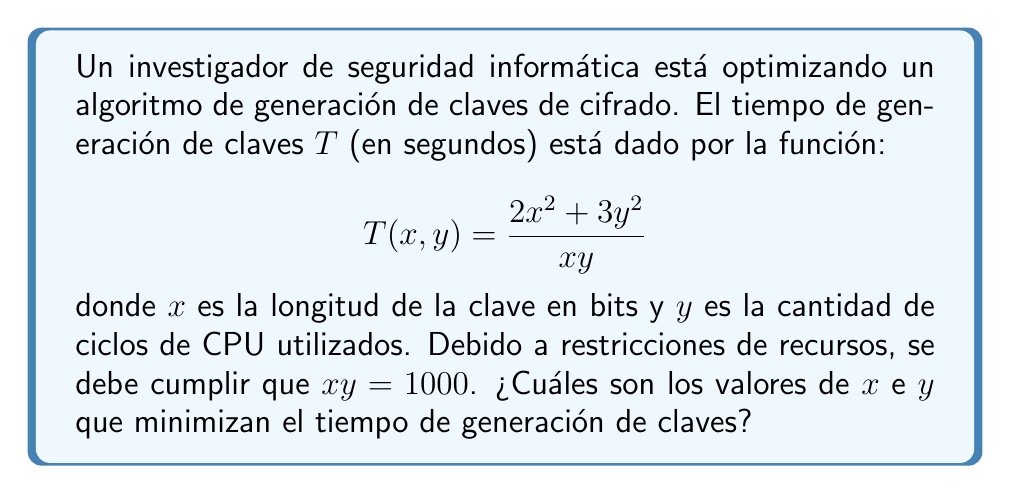Teach me how to tackle this problem. Para resolver este problema de optimización con restricciones, seguiremos estos pasos:

1) Primero, expresamos $y$ en términos de $x$ usando la restricción:
   $xy = 1000 \implies y = \frac{1000}{x}$

2) Sustituimos esto en la función objetivo:
   $$T(x) = \frac{2x^2 + 3(\frac{1000}{x})^2}{x(\frac{1000}{x})} = \frac{2x^2 + 3,000,000/x^2}{1000}$$

3) Simplificamos:
   $$T(x) = \frac{2x^4 + 3,000,000}{1000x^2}$$

4) Para encontrar el mínimo, derivamos $T(x)$ e igualamos a cero:
   $$T'(x) = \frac{8x^3 \cdot 1000x^2 - (2x^4 + 3,000,000) \cdot 2000x}{(1000x^2)^2} = 0$$

5) Simplificamos:
   $$8x^5 - 4x^5 - 6,000,000x = 0$$
   $$4x^5 - 6,000,000x = 0$$
   $$4x^4 - 6,000,000 = 0$$

6) Resolvemos:
   $$x^4 = 1,500,000$$
   $$x = \sqrt[4]{1,500,000} \approx 61.24$$

7) Redondeamos a 61 bits, ya que la longitud de la clave debe ser un número entero.

8) Calculamos $y$:
   $$y = \frac{1000}{x} \approx \frac{1000}{61} \approx 16.39$$

9) Redondeamos $y$ a 16 ciclos de CPU para mantener la restricción lo más cerca posible de 1000.
Answer: La longitud óptima de la clave es $x = 61$ bits, utilizando $y = 16$ ciclos de CPU. 